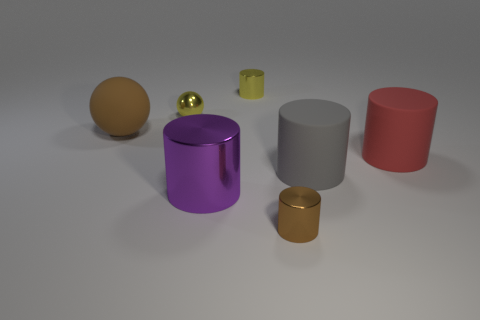The big gray object that is the same material as the red object is what shape?
Provide a succinct answer. Cylinder. Is the number of red things that are in front of the purple thing less than the number of brown matte spheres?
Make the answer very short. Yes. Does the gray thing have the same shape as the large brown thing?
Your answer should be very brief. No. How many metallic objects are either big red cylinders or large gray cylinders?
Your answer should be compact. 0. Are there any purple metallic cylinders that have the same size as the brown matte object?
Offer a very short reply. Yes. What shape is the metal thing that is the same color as the matte sphere?
Your answer should be very brief. Cylinder. What number of yellow balls have the same size as the brown ball?
Your response must be concise. 0. There is a cylinder that is behind the small yellow metal sphere; is it the same size as the thing that is on the left side of the yellow metal sphere?
Offer a very short reply. No. What number of objects are purple objects or tiny yellow objects on the left side of the gray cylinder?
Offer a very short reply. 3. What color is the metallic sphere?
Your answer should be compact. Yellow. 